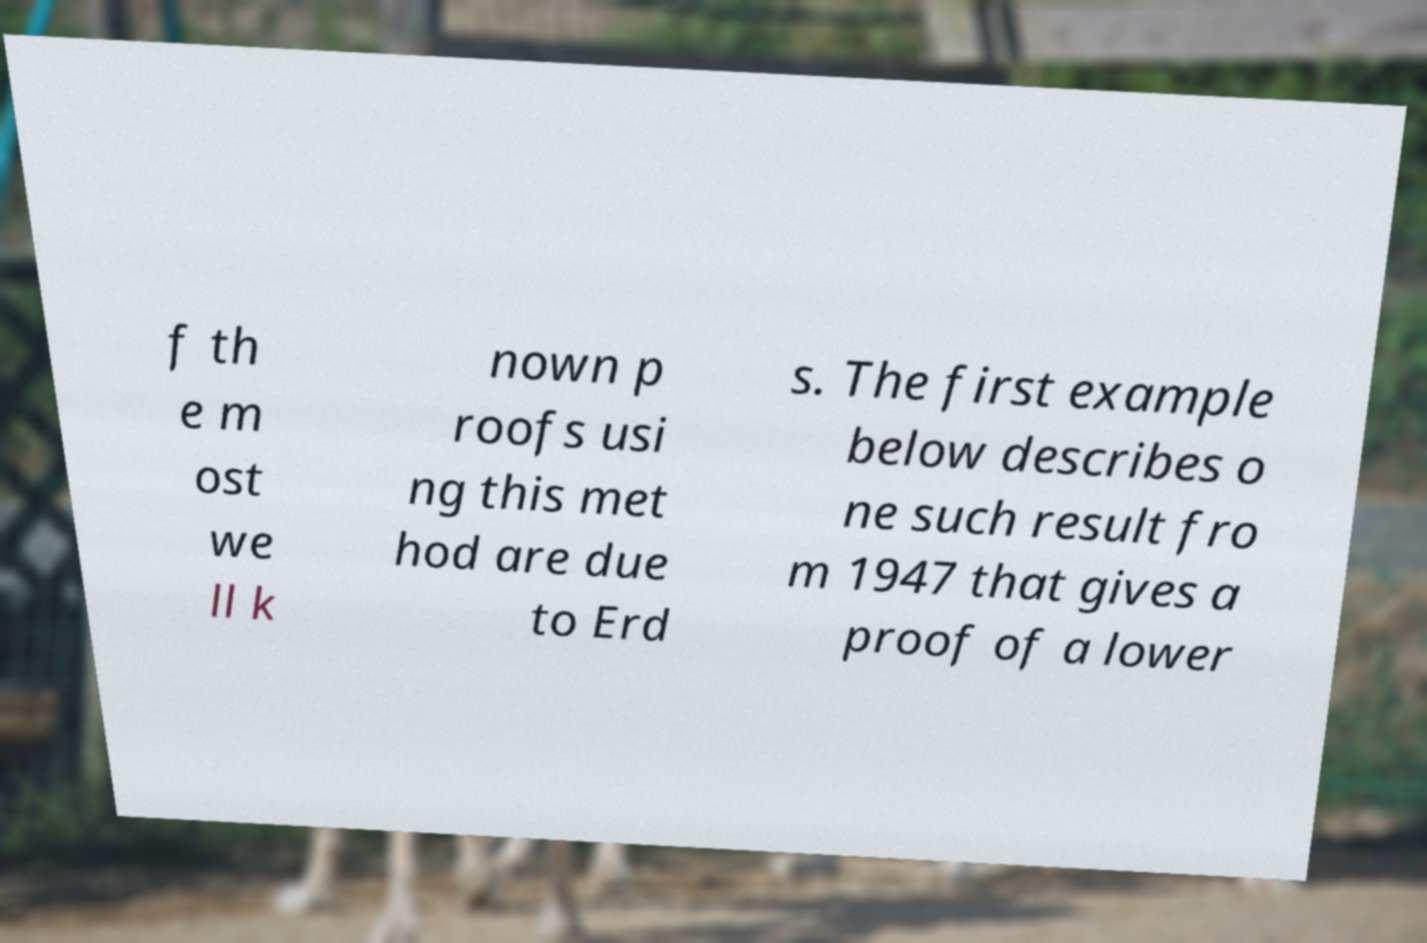What messages or text are displayed in this image? I need them in a readable, typed format. f th e m ost we ll k nown p roofs usi ng this met hod are due to Erd s. The first example below describes o ne such result fro m 1947 that gives a proof of a lower 